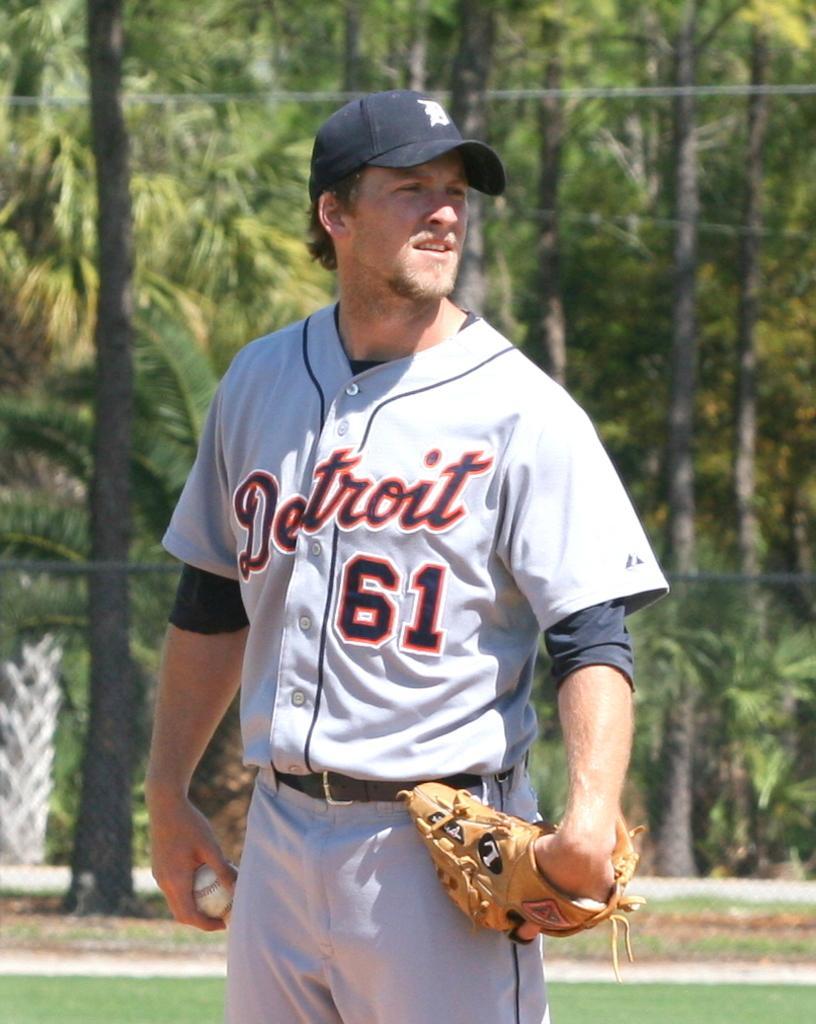Please provide a concise description of this image. In this picture we see a man standing and looking at someone. The man has a ball and a glove in his hands. He is wearing a cap. Behind him we can see trees. 